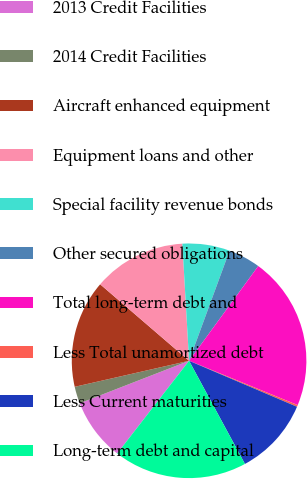<chart> <loc_0><loc_0><loc_500><loc_500><pie_chart><fcel>2013 Credit Facilities<fcel>2014 Credit Facilities<fcel>Aircraft enhanced equipment<fcel>Equipment loans and other<fcel>Special facility revenue bonds<fcel>Other secured obligations<fcel>Total long-term debt and<fcel>Less Total unamortized debt<fcel>Less Current maturities<fcel>Long-term debt and capital<nl><fcel>8.6%<fcel>2.34%<fcel>14.87%<fcel>12.78%<fcel>6.52%<fcel>4.43%<fcel>21.13%<fcel>0.25%<fcel>10.69%<fcel>18.4%<nl></chart> 